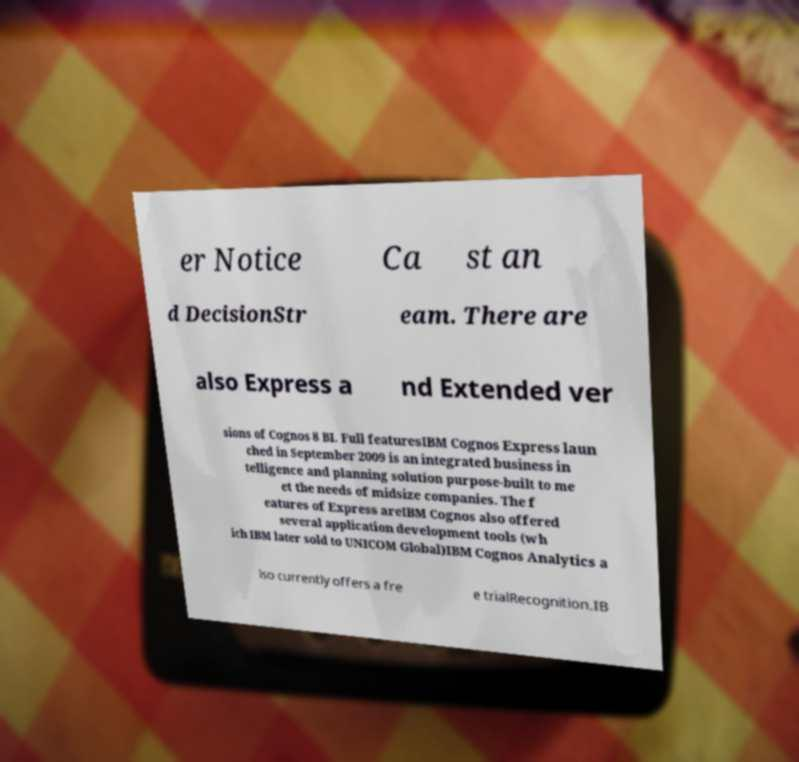Could you assist in decoding the text presented in this image and type it out clearly? er Notice Ca st an d DecisionStr eam. There are also Express a nd Extended ver sions of Cognos 8 BI. Full featuresIBM Cognos Express laun ched in September 2009 is an integrated business in telligence and planning solution purpose-built to me et the needs of midsize companies. The f eatures of Express areIBM Cognos also offered several application development tools (wh ich IBM later sold to UNICOM Global)IBM Cognos Analytics a lso currently offers a fre e trialRecognition.IB 